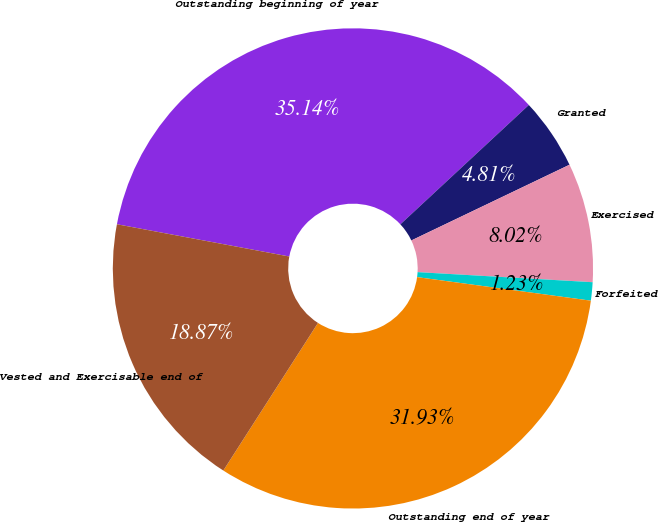Convert chart. <chart><loc_0><loc_0><loc_500><loc_500><pie_chart><fcel>Outstanding beginning of year<fcel>Granted<fcel>Exercised<fcel>Forfeited<fcel>Outstanding end of year<fcel>Vested and Exercisable end of<nl><fcel>35.14%<fcel>4.81%<fcel>8.02%<fcel>1.23%<fcel>31.93%<fcel>18.87%<nl></chart> 